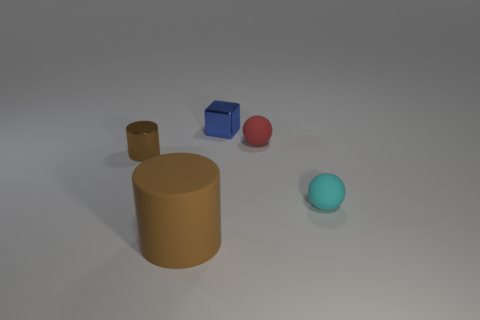Subtract all cyan spheres. How many spheres are left? 1 Add 2 small blue shiny objects. How many objects exist? 7 Subtract all blue spheres. How many red cylinders are left? 0 Subtract all cyan rubber spheres. Subtract all large blocks. How many objects are left? 4 Add 1 tiny cyan rubber objects. How many tiny cyan rubber objects are left? 2 Add 5 big cyan matte blocks. How many big cyan matte blocks exist? 5 Subtract 0 cyan cubes. How many objects are left? 5 Subtract all cylinders. How many objects are left? 3 Subtract all cyan spheres. Subtract all yellow cylinders. How many spheres are left? 1 